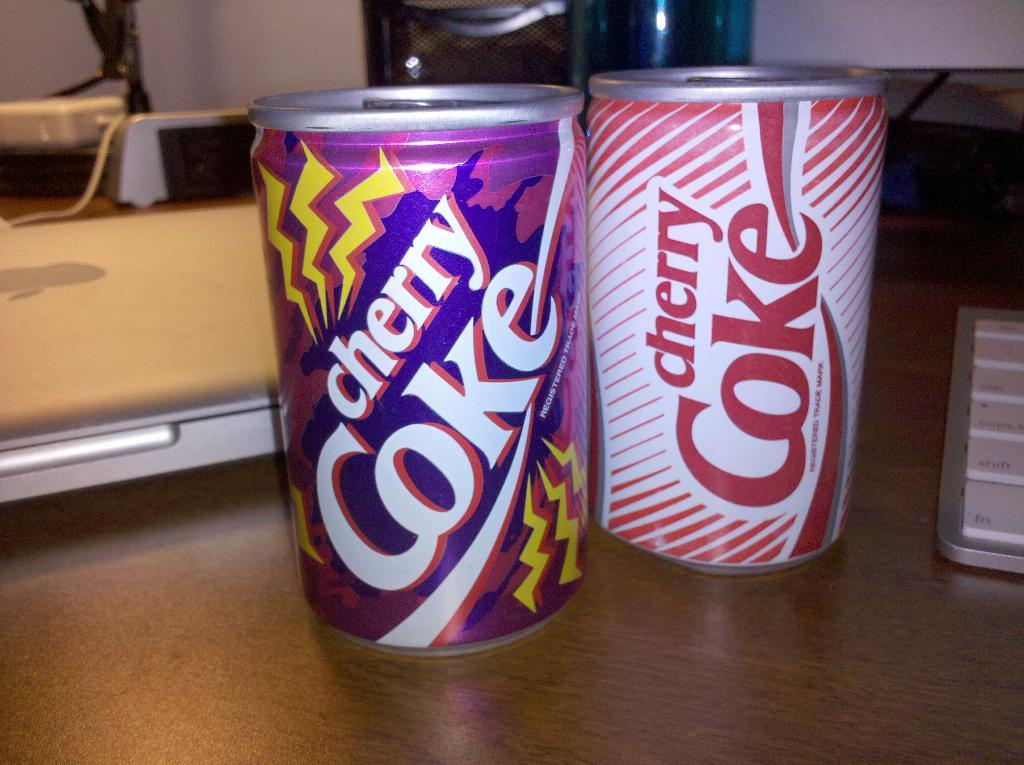<image>
Relay a brief, clear account of the picture shown. Two cans of cherry Coke sit next to each other on a wooden desk. 